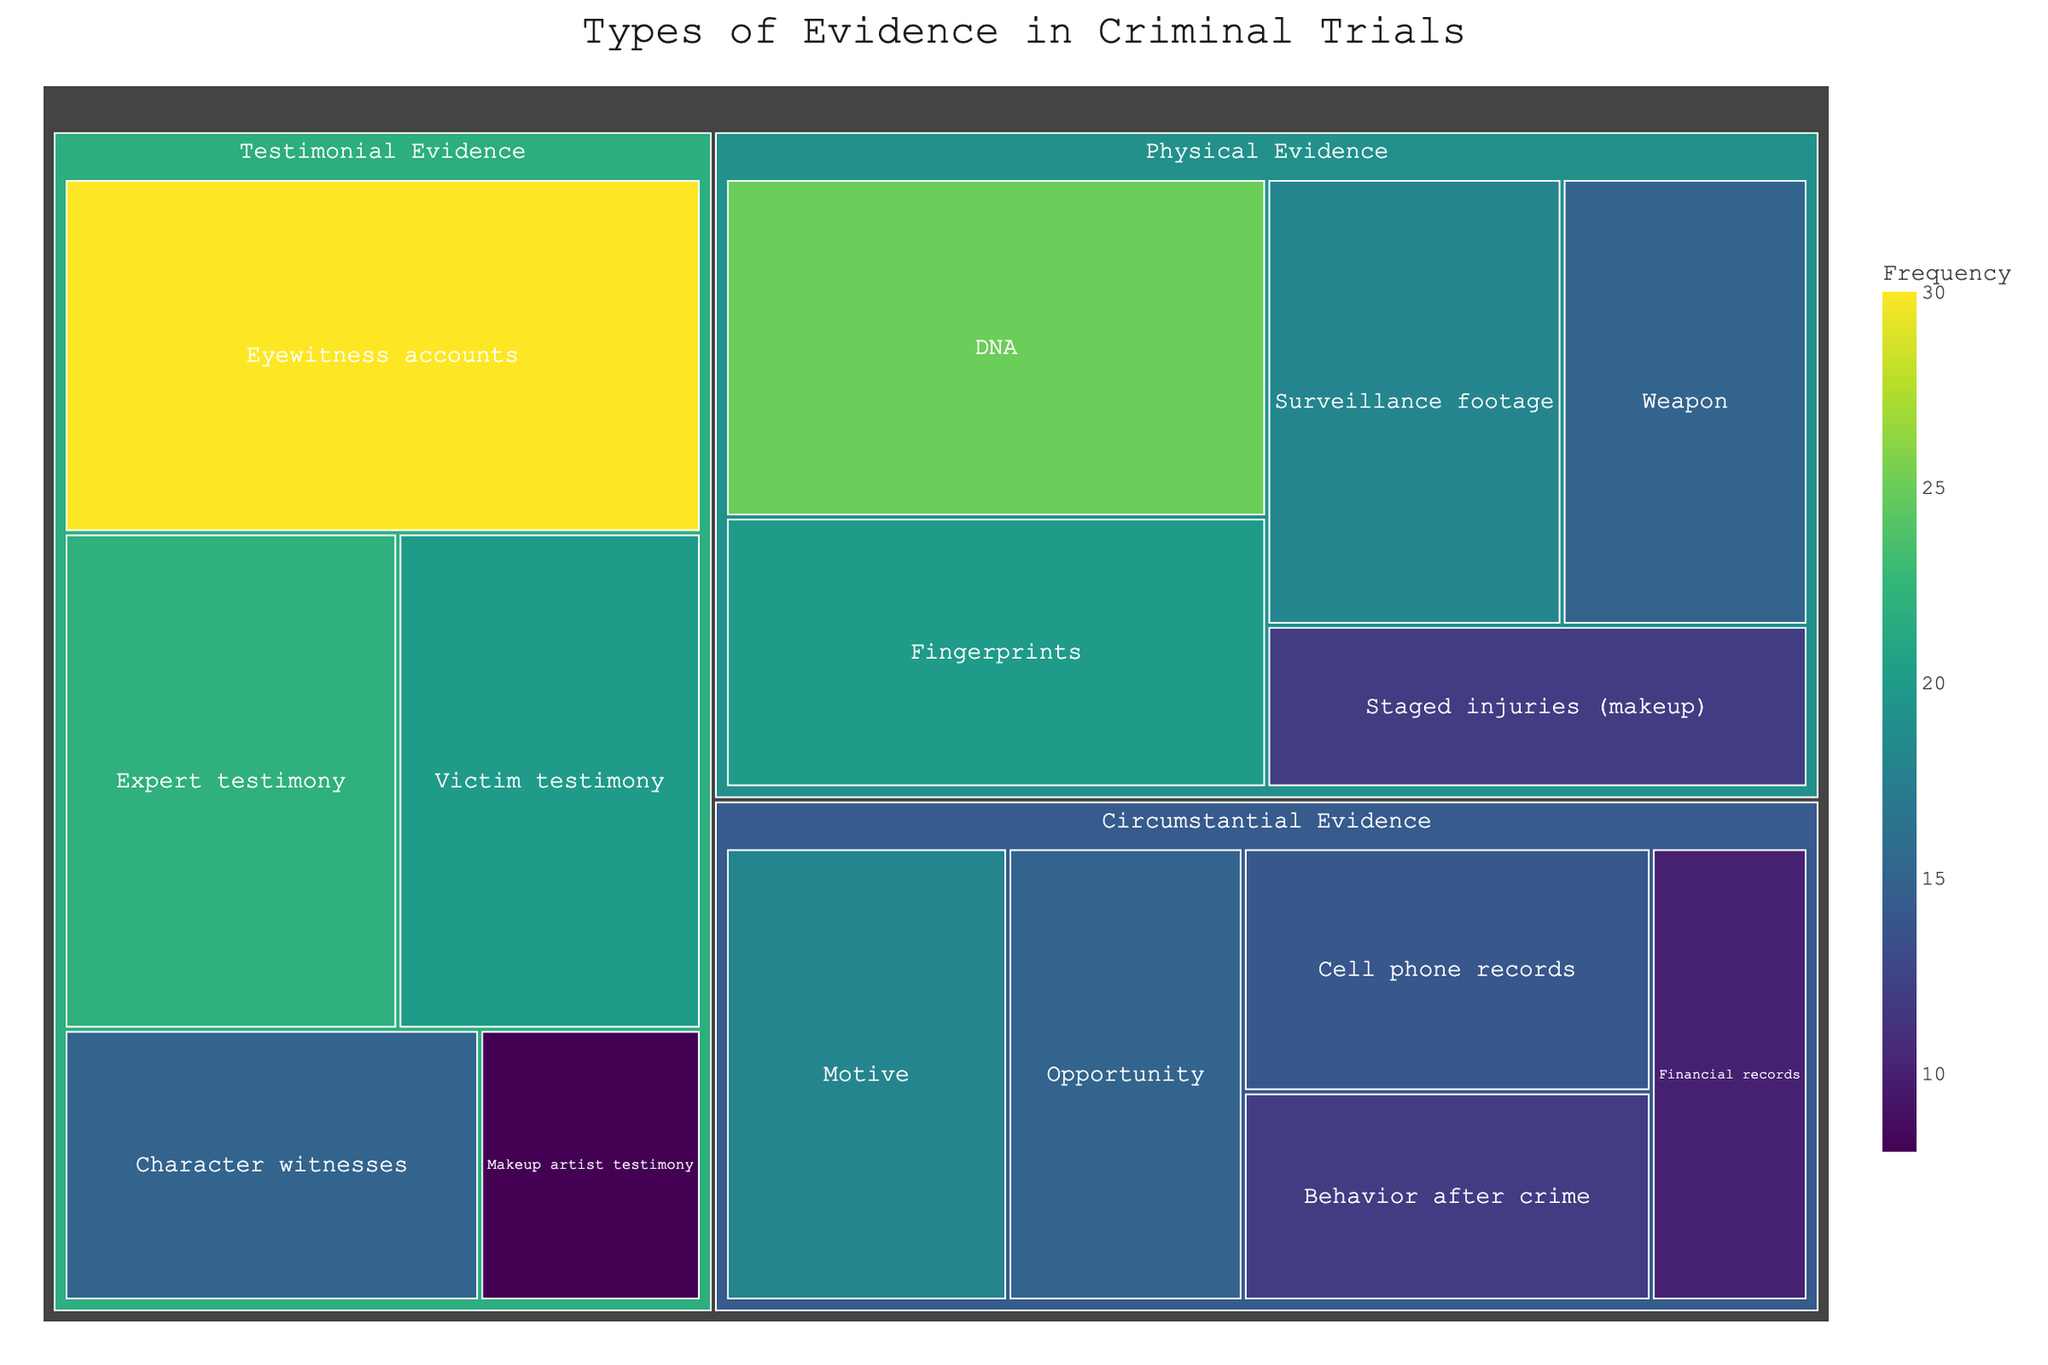What is the title of the treemap? The title of the treemap is usually displayed prominently at the top of the figure. In this case, the title specified is "Types of Evidence in Criminal Trials".
Answer: Types of Evidence in Criminal Trials How many categories of evidence are there in the treemap? The treemap categorizes the evidence into three main categories: Physical Evidence, Testimonial Evidence, and Circumstantial Evidence. These categories are visually distinct on the plot.
Answer: Three Which type of evidence has the highest frequency under Testimonial Evidence? The treemap shows the frequency of each type of evidence within their respective categories. Under Testimonial Evidence, Eyewitness accounts have the highest frequency of 30.
Answer: Eyewitness accounts What is the total frequency of Physical Evidence types? To find the total frequency of Physical Evidence types, sum the frequencies of each type within this category: 25 (DNA) + 20 (Fingerprints) + 15 (Weapon) + 18 (Surveillance footage) + 12 (Staged injuries) = 90.
Answer: 90 Which type has a higher frequency, Financial records or Cell phone records? Compare the frequencies shown on the treemap for Financial records and Cell phone records. Financial records have a frequency of 10, while Cell phone records have a frequency of 14.
Answer: Cell phone records What is the least frequent type of evidence in the entire treemap? To identify the least frequent type, locate the data point with the smallest frequency value in the treemap. Makeup artist testimony under Testimonial Evidence has the least frequency with a value of 8.
Answer: Makeup artist testimony Which category has the most diverse types of evidence? To determine this, count the number of types under each category. All categories (Physical Evidence, Testimonial Evidence, and Circumstantial Evidence) have 5 types each. Therefore, they all have equal diversity.
Answer: All categories What is the frequency difference between DNA evidence and Weapon evidence? Subtract the frequency of Weapon evidence from that of DNA evidence: 25 (DNA) - 15 (Weapon) = 10.
Answer: 10 Which category contains the evidence type 'Staged injuries (makeup)'? The treemap categorizes each type of evidence under a specific category. 'Staged injuries (makeup)' is listed under Physical Evidence.
Answer: Physical Evidence How many evidence types have a frequency greater than 20? Examine the frequencies for each evidence type across the entire treemap. The types with frequencies greater than 20 are DNA (25), Eyewitness accounts (30), and Expert testimony (22). Thus, there are three such evidence types.
Answer: Three 